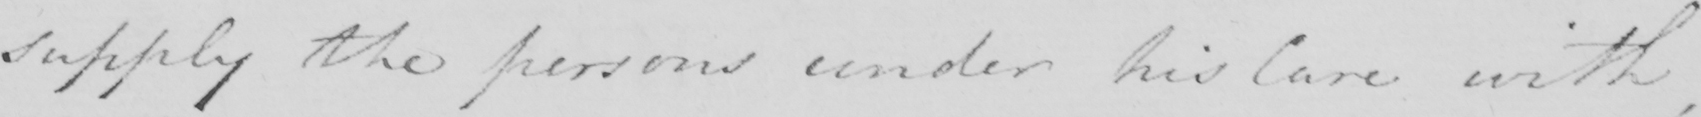Can you read and transcribe this handwriting? supply the persons under his Care with , 